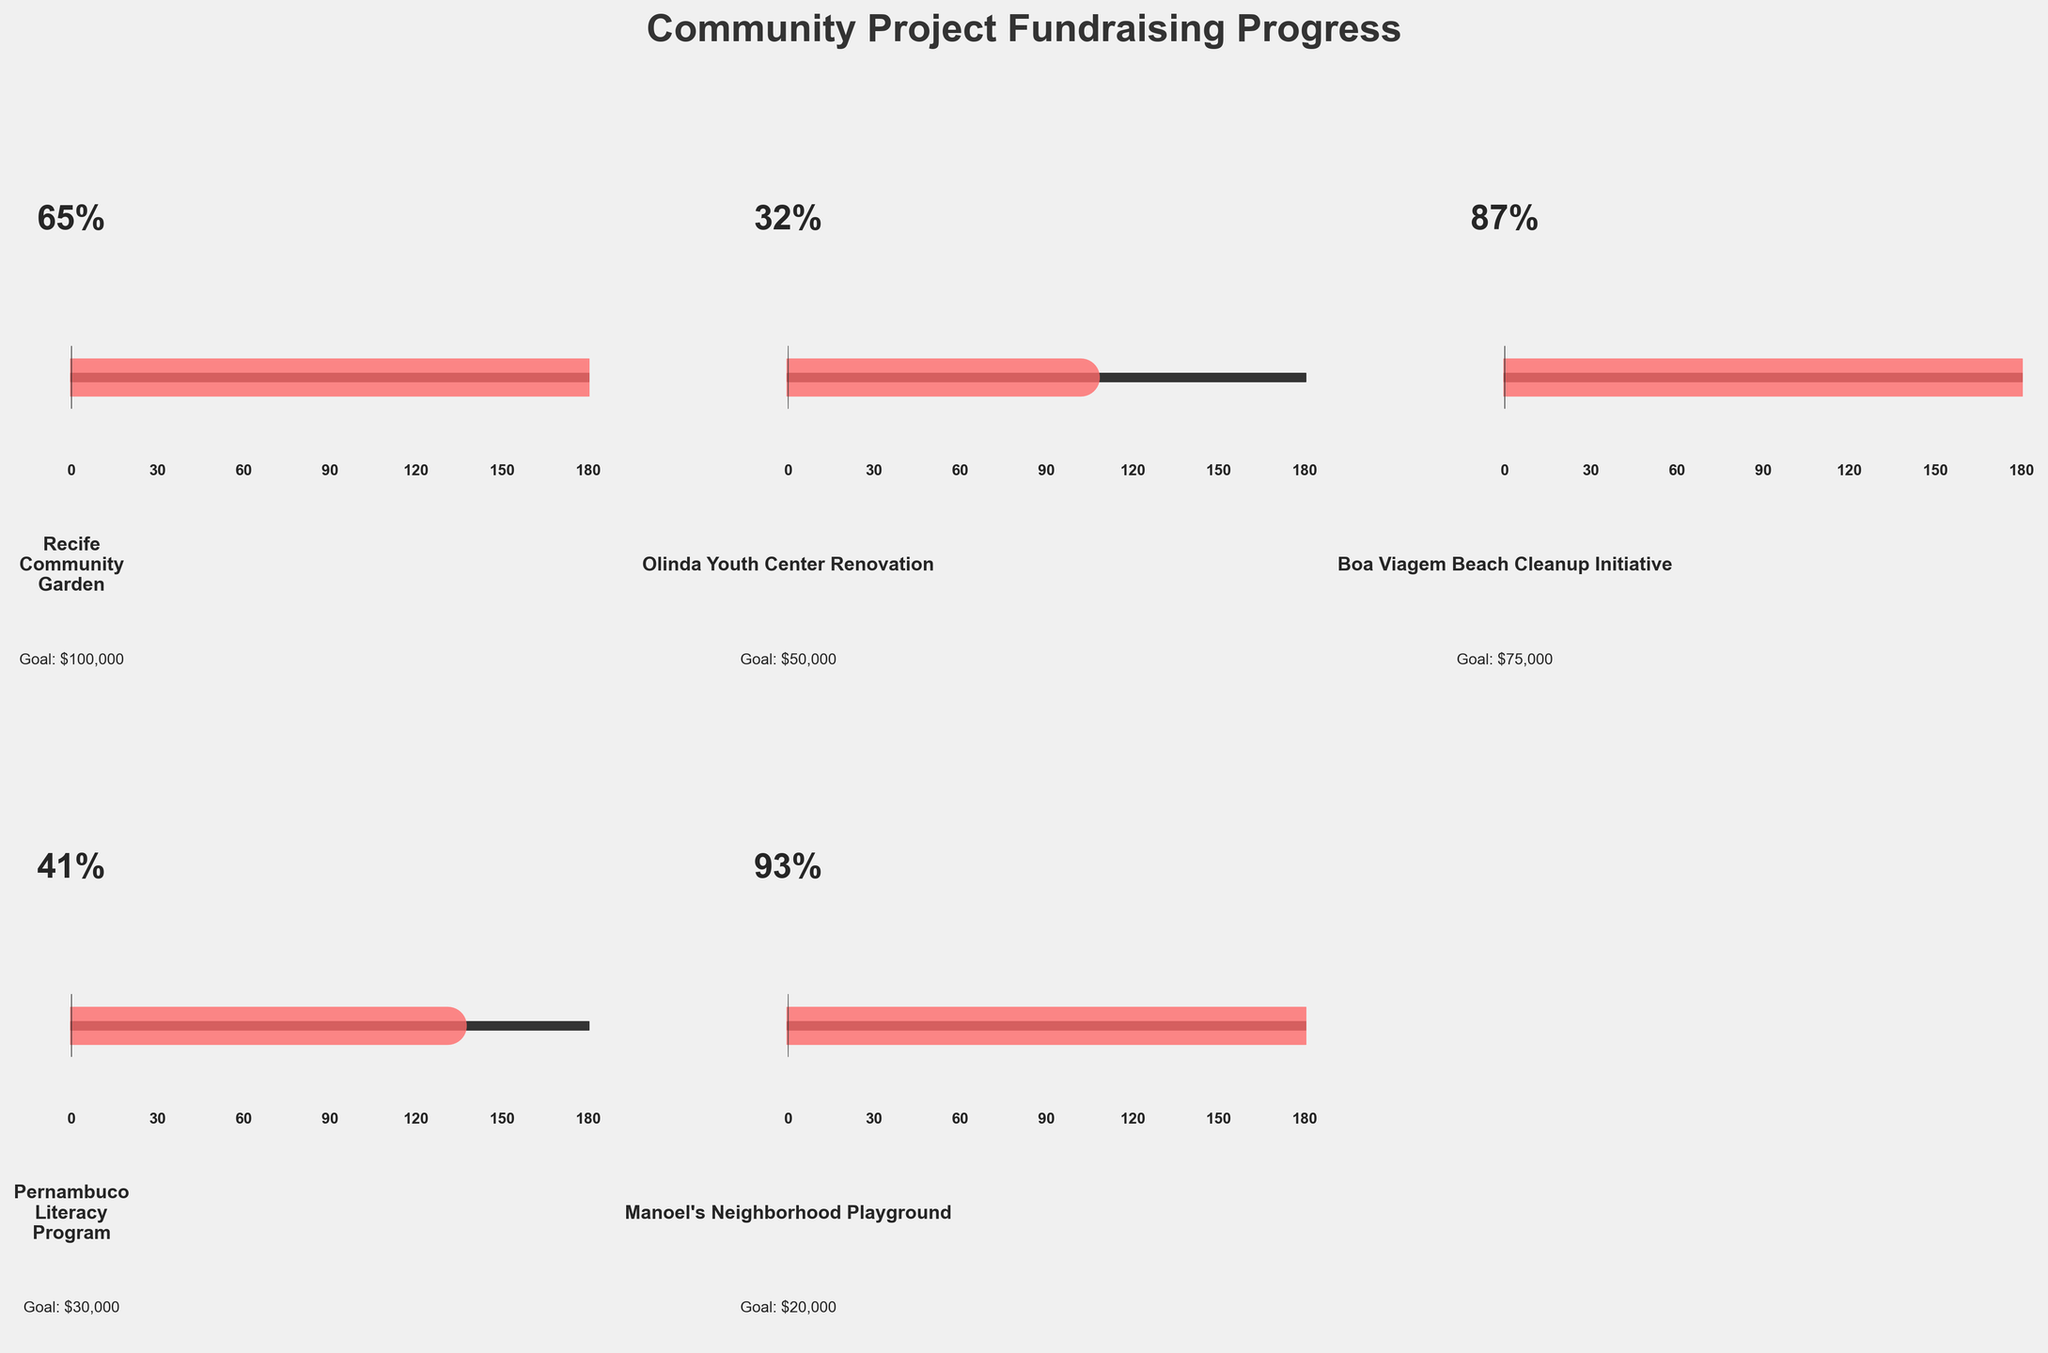What is the highest fundraising progress percentage among the projects? Look for the highest percentage value presented on the gauge chart.
Answer: 93% Which project has the lowest fundraising progress percentage? Identify the project with the smallest percentage value on the gauge chart.
Answer: Olinda Youth Center Renovation What is the fundraising goal for "Recife Community Garden"? Look at the label underneath the gauge for the "Recife Community Garden" to find the goal amount.
Answer: $100,000 Which project is closest to achieving its fundraising goal? Compare the percentage progress of each project and look for the one closest to 100%.
Answer: Manoel's Neighborhood Playground Which project has a fundraising goal of $30,000? Identify the project associated with the $30,000 goal by looking at the labels.
Answer: Pernambuco Literacy Program What is the average fundraising progress percentage of all projects? Sum all percentages and divide by the number of projects: (65 + 32 + 87 + 41 + 93) / 5 = 63.6
Answer: 63.6% How much more percentage does "Boa Viagem Beach Cleanup Initiative" need to reach its goal? Subtract the current percentage from 100: 100 - 87 = 13
Answer: 13% Which project has the second highest fundraising progress percentage? Identify the second highest percentage value on the gauge chart.
Answer: Boa Viagem Beach Cleanup Initiative How much money has "Olinda Youth Center Renovation" raised so far? Calculate the amount by applying the percentage to the goal: 32% of $50,000 = 0.32 * 50000 = $16,000
Answer: $16,000 Which two projects have a percentage difference of 26% in their fundraising progress? Compare pairs of projects to find the one with a 26% difference: 65% (Recife Community Garden) - 41% (Pernambuco Literacy Program) = 24%. 87% (Boa Viagem Beach Cleanup Initiative) - 41% (Pernambuco Literacy Program) = 46%. 93% (Manoel's Neighborhood Playground) - 65% (Recife Community Garden) = 28%. 87% (Boa Viagem Beach Cleanup Initiative) - 65% (Recife Community Garden) = 22%. 93% (Manoel's Neighborhood Playground) - 67% (Olinda Youth Center Renovation) = 61%. 93% (Manoel's Neighborhood Playground) - 65% (Recife Community Garden) = 28%. 93% (Manoel's Neighborhood Playground) - 87% (Boa Viagem Beach Cleanup Initiative) = 6%. 65% (Recife Community Garden) - 32% (Olinda Youth Center Renovation) = 33%. 41% - 65% = 24. 65% and 93% = highest percentages. 93% - 65% = 28%. Closest answer: 28.
Answer: Second: Boa Viagem Beach Cleanup Intitiative, 46% 